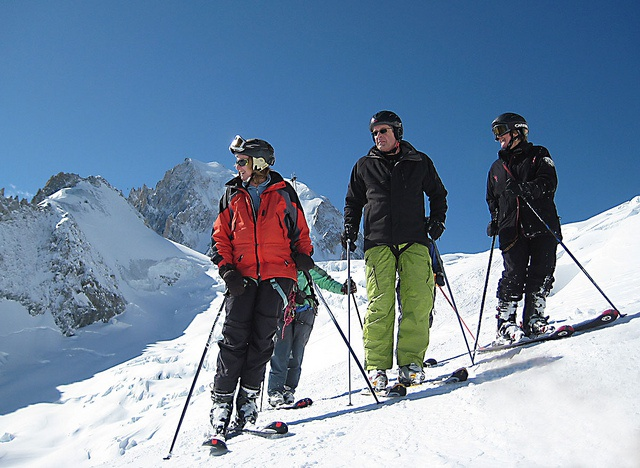Describe the objects in this image and their specific colors. I can see people in gray, black, brown, and maroon tones, people in gray, black, darkgreen, and olive tones, people in gray, black, white, and darkgray tones, people in gray, black, and blue tones, and skis in gray, black, navy, and darkgray tones in this image. 